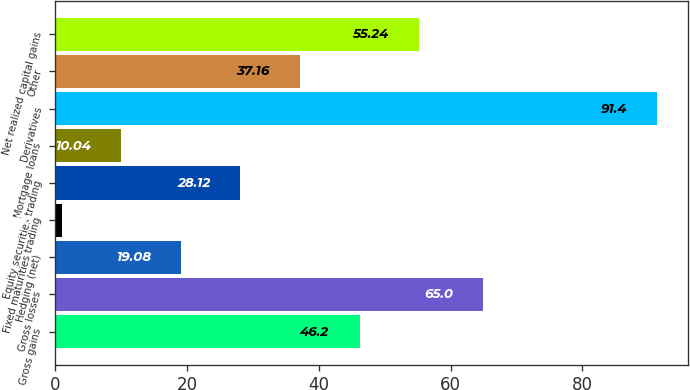<chart> <loc_0><loc_0><loc_500><loc_500><bar_chart><fcel>Gross gains<fcel>Gross losses<fcel>Hedging (net)<fcel>Fixed maturities trading<fcel>Equity securities trading<fcel>Mortgage loans<fcel>Derivatives<fcel>Other<fcel>Net realized capital gains<nl><fcel>46.2<fcel>65<fcel>19.08<fcel>1<fcel>28.12<fcel>10.04<fcel>91.4<fcel>37.16<fcel>55.24<nl></chart> 